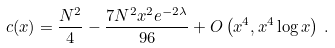<formula> <loc_0><loc_0><loc_500><loc_500>c ( x ) = \frac { N ^ { 2 } } { 4 } - \frac { 7 N ^ { 2 } x ^ { 2 } e ^ { - 2 \lambda } } { 9 6 } + O \left ( x ^ { 4 } , x ^ { 4 } \log { x } \right ) \, .</formula> 